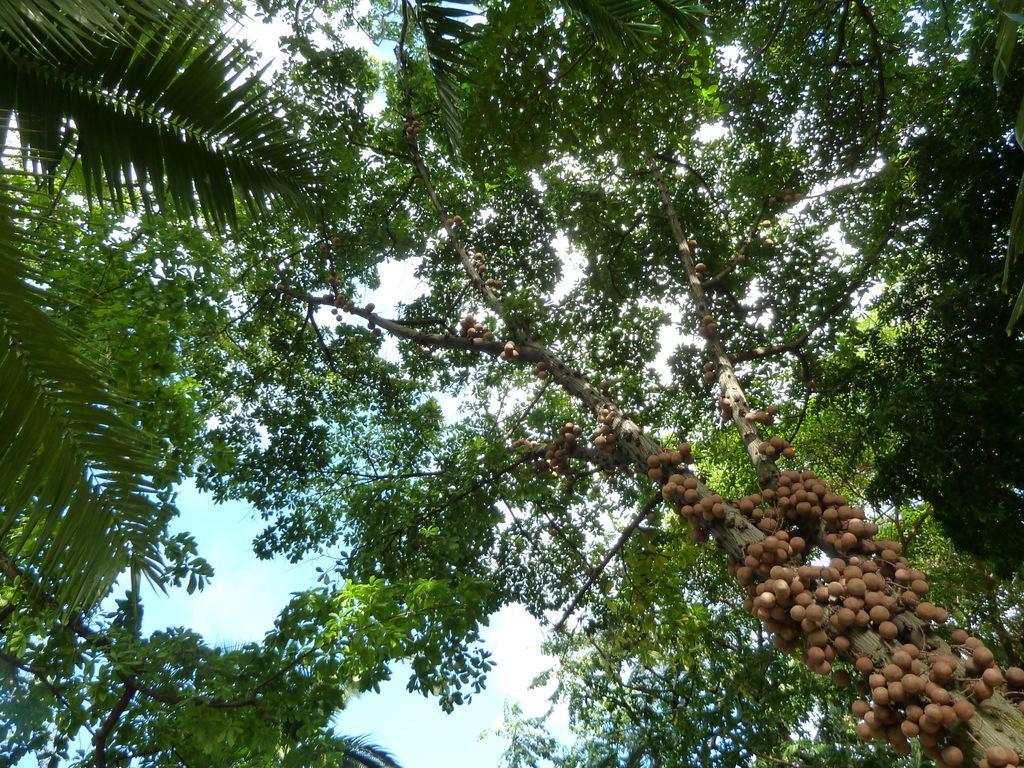How would you summarize this image in a sentence or two? In this image there are some fruits at the trunk of the tree also there are some trees around. 